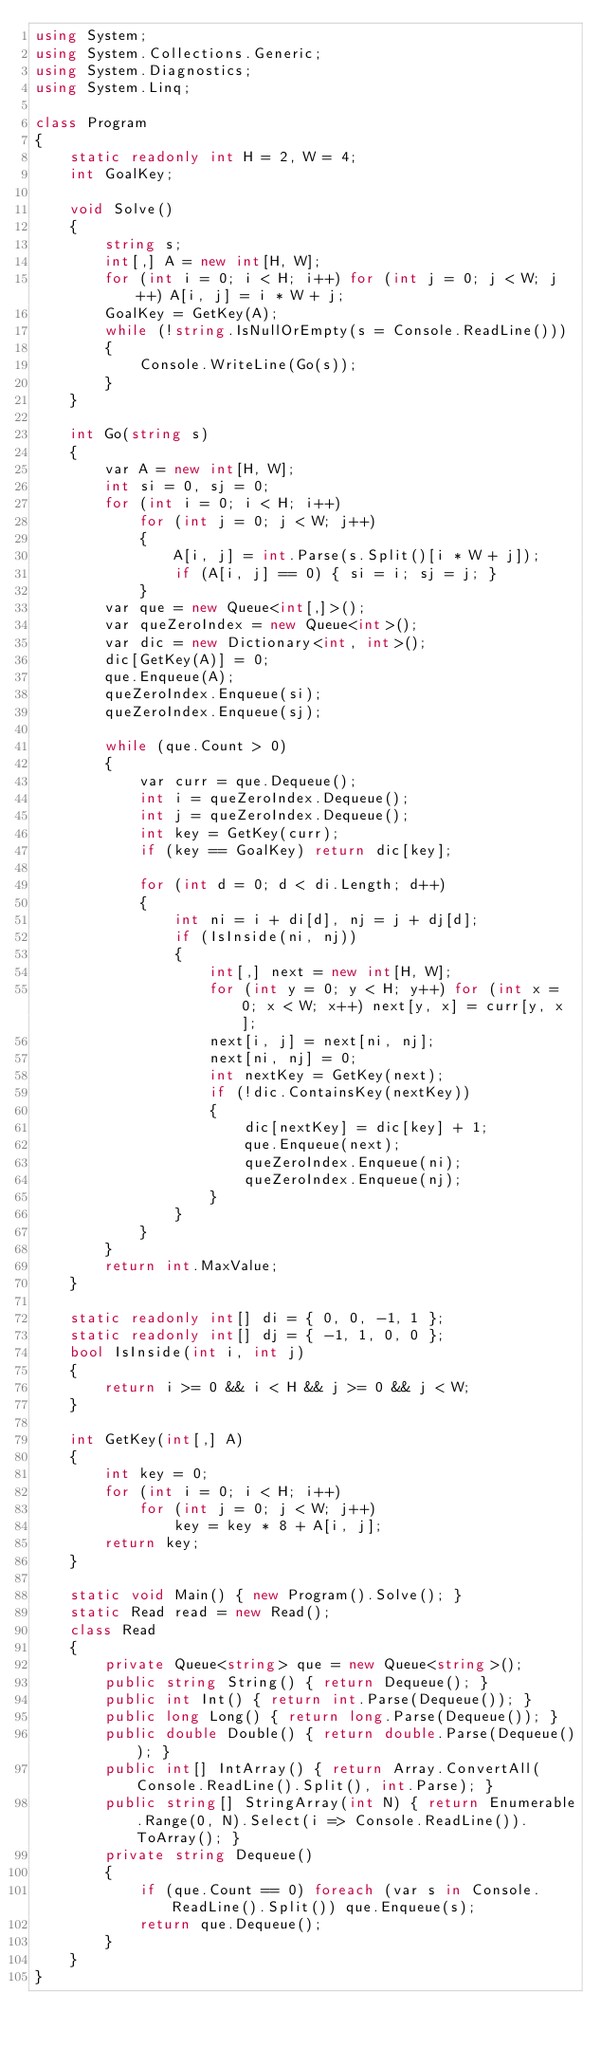Convert code to text. <code><loc_0><loc_0><loc_500><loc_500><_C#_>using System;
using System.Collections.Generic;
using System.Diagnostics;
using System.Linq;

class Program
{
    static readonly int H = 2, W = 4;
    int GoalKey;

    void Solve()
    {
        string s;
        int[,] A = new int[H, W];
        for (int i = 0; i < H; i++) for (int j = 0; j < W; j++) A[i, j] = i * W + j;
        GoalKey = GetKey(A);
        while (!string.IsNullOrEmpty(s = Console.ReadLine()))
        {
            Console.WriteLine(Go(s));
        }
    }

    int Go(string s)
    {
        var A = new int[H, W];
        int si = 0, sj = 0;
        for (int i = 0; i < H; i++)
            for (int j = 0; j < W; j++)
            {
                A[i, j] = int.Parse(s.Split()[i * W + j]);
                if (A[i, j] == 0) { si = i; sj = j; }
            }
        var que = new Queue<int[,]>();
        var queZeroIndex = new Queue<int>();
        var dic = new Dictionary<int, int>();
        dic[GetKey(A)] = 0;
        que.Enqueue(A);
        queZeroIndex.Enqueue(si);
        queZeroIndex.Enqueue(sj);

        while (que.Count > 0)
        {
            var curr = que.Dequeue();
            int i = queZeroIndex.Dequeue();
            int j = queZeroIndex.Dequeue();
            int key = GetKey(curr);
            if (key == GoalKey) return dic[key];

            for (int d = 0; d < di.Length; d++)
            {
                int ni = i + di[d], nj = j + dj[d];
                if (IsInside(ni, nj))
                {
                    int[,] next = new int[H, W];
                    for (int y = 0; y < H; y++) for (int x = 0; x < W; x++) next[y, x] = curr[y, x];
                    next[i, j] = next[ni, nj];
                    next[ni, nj] = 0;
                    int nextKey = GetKey(next);
                    if (!dic.ContainsKey(nextKey))
                    {
                        dic[nextKey] = dic[key] + 1;
                        que.Enqueue(next);
                        queZeroIndex.Enqueue(ni);
                        queZeroIndex.Enqueue(nj);
                    }
                }
            }
        }
        return int.MaxValue;
    }

    static readonly int[] di = { 0, 0, -1, 1 };
    static readonly int[] dj = { -1, 1, 0, 0 };
    bool IsInside(int i, int j)
    {
        return i >= 0 && i < H && j >= 0 && j < W;
    }

    int GetKey(int[,] A)
    {
        int key = 0;
        for (int i = 0; i < H; i++)
            for (int j = 0; j < W; j++)
                key = key * 8 + A[i, j];
        return key;
    }

    static void Main() { new Program().Solve(); }
    static Read read = new Read();
    class Read
    {
        private Queue<string> que = new Queue<string>();
        public string String() { return Dequeue(); }
        public int Int() { return int.Parse(Dequeue()); }
        public long Long() { return long.Parse(Dequeue()); }
        public double Double() { return double.Parse(Dequeue()); }
        public int[] IntArray() { return Array.ConvertAll(Console.ReadLine().Split(), int.Parse); }
        public string[] StringArray(int N) { return Enumerable.Range(0, N).Select(i => Console.ReadLine()).ToArray(); }
        private string Dequeue()
        {
            if (que.Count == 0) foreach (var s in Console.ReadLine().Split()) que.Enqueue(s);
            return que.Dequeue();
        }
    }
}</code> 